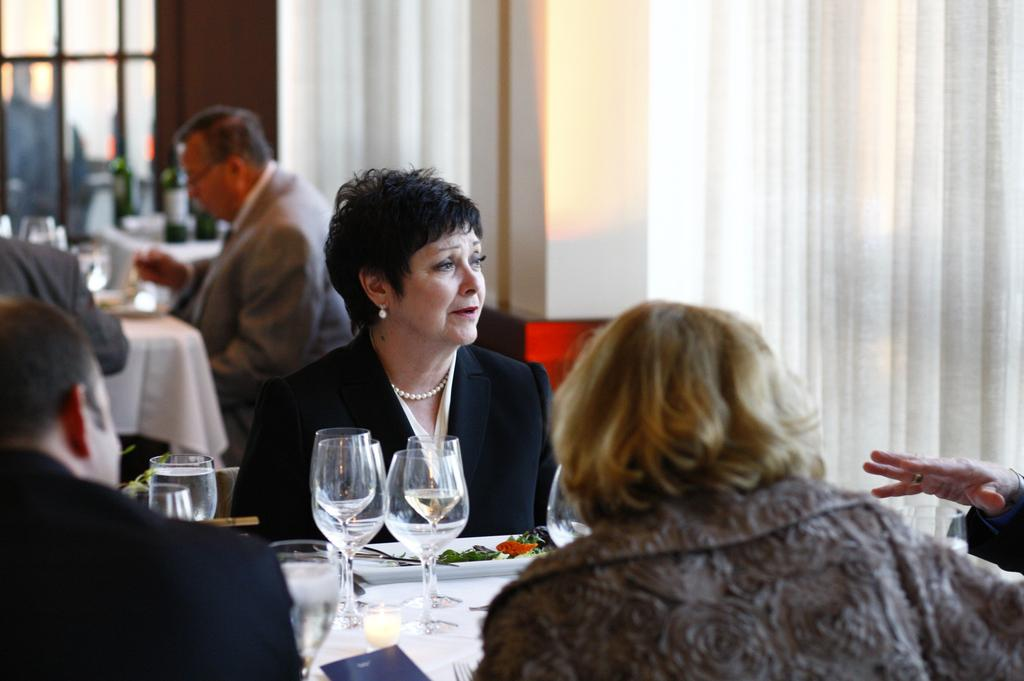What type of covering can be seen in the image? There is a curtain in the image. What are the people in the image doing? The people are sitting on chairs in the image. What furniture is present in the image? There is a table in the image. What items are on the table? There are glasses and plates on the table. Can you describe the skin of the stranger in the image? There is no stranger present in the image, so we cannot describe their skin. How many chairs are visible in the image? The image shows people sitting on chairs, but it does not specify the exact number of chairs. 